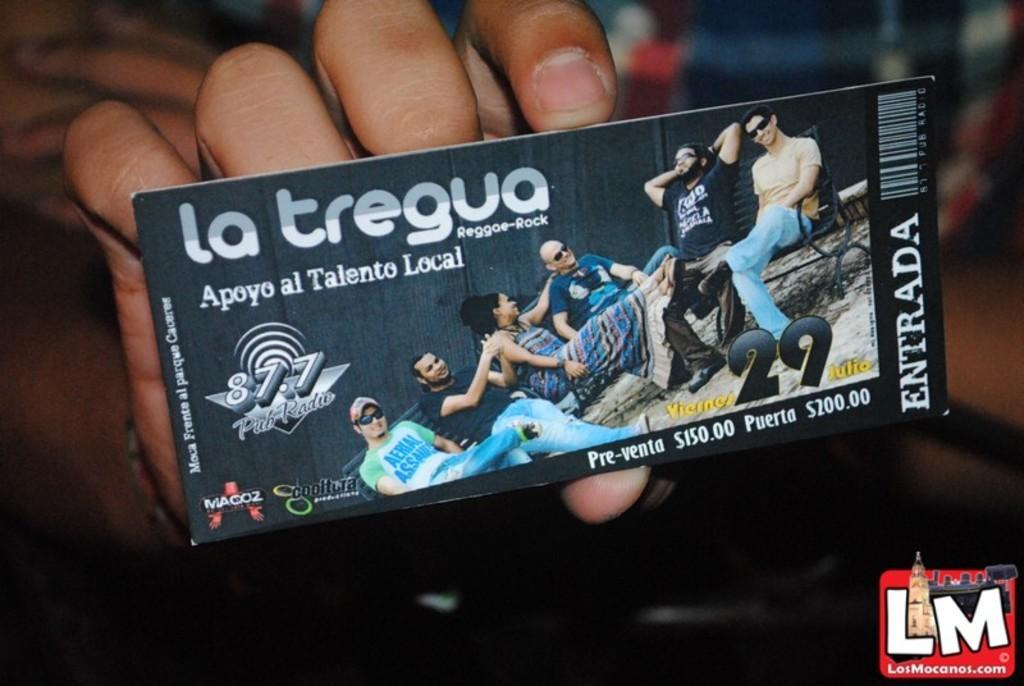Could you give a brief overview of what you see in this image? In this picture we can see the fingers of a person holding a ticket. On this ticket, we can see some text, numbers and a few people. Background is blurry. 